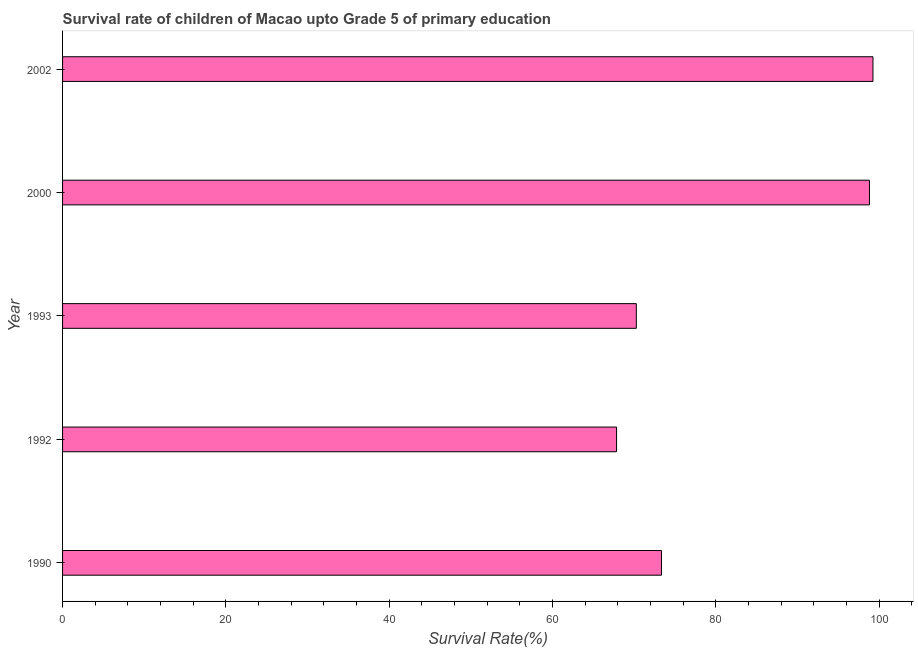Does the graph contain grids?
Provide a short and direct response. No. What is the title of the graph?
Provide a short and direct response. Survival rate of children of Macao upto Grade 5 of primary education. What is the label or title of the X-axis?
Give a very brief answer. Survival Rate(%). What is the survival rate in 1993?
Your answer should be very brief. 70.25. Across all years, what is the maximum survival rate?
Offer a terse response. 99.23. Across all years, what is the minimum survival rate?
Give a very brief answer. 67.83. In which year was the survival rate maximum?
Your answer should be compact. 2002. What is the sum of the survival rate?
Provide a short and direct response. 409.44. What is the difference between the survival rate in 1992 and 2002?
Your response must be concise. -31.39. What is the average survival rate per year?
Provide a short and direct response. 81.89. What is the median survival rate?
Make the answer very short. 73.33. In how many years, is the survival rate greater than 44 %?
Offer a terse response. 5. Do a majority of the years between 1990 and 1993 (inclusive) have survival rate greater than 72 %?
Provide a succinct answer. No. What is the ratio of the survival rate in 1990 to that in 1992?
Make the answer very short. 1.08. Is the difference between the survival rate in 2000 and 2002 greater than the difference between any two years?
Offer a very short reply. No. What is the difference between the highest and the second highest survival rate?
Your answer should be compact. 0.43. What is the difference between the highest and the lowest survival rate?
Provide a short and direct response. 31.4. What is the Survival Rate(%) in 1990?
Provide a short and direct response. 73.33. What is the Survival Rate(%) in 1992?
Your answer should be compact. 67.83. What is the Survival Rate(%) in 1993?
Your answer should be very brief. 70.25. What is the Survival Rate(%) of 2000?
Provide a succinct answer. 98.8. What is the Survival Rate(%) in 2002?
Provide a short and direct response. 99.23. What is the difference between the Survival Rate(%) in 1990 and 1992?
Your answer should be compact. 5.5. What is the difference between the Survival Rate(%) in 1990 and 1993?
Provide a succinct answer. 3.08. What is the difference between the Survival Rate(%) in 1990 and 2000?
Keep it short and to the point. -25.47. What is the difference between the Survival Rate(%) in 1990 and 2002?
Offer a very short reply. -25.9. What is the difference between the Survival Rate(%) in 1992 and 1993?
Keep it short and to the point. -2.42. What is the difference between the Survival Rate(%) in 1992 and 2000?
Offer a terse response. -30.96. What is the difference between the Survival Rate(%) in 1992 and 2002?
Your answer should be very brief. -31.4. What is the difference between the Survival Rate(%) in 1993 and 2000?
Keep it short and to the point. -28.54. What is the difference between the Survival Rate(%) in 1993 and 2002?
Ensure brevity in your answer.  -28.98. What is the difference between the Survival Rate(%) in 2000 and 2002?
Ensure brevity in your answer.  -0.43. What is the ratio of the Survival Rate(%) in 1990 to that in 1992?
Provide a short and direct response. 1.08. What is the ratio of the Survival Rate(%) in 1990 to that in 1993?
Provide a succinct answer. 1.04. What is the ratio of the Survival Rate(%) in 1990 to that in 2000?
Your answer should be very brief. 0.74. What is the ratio of the Survival Rate(%) in 1990 to that in 2002?
Ensure brevity in your answer.  0.74. What is the ratio of the Survival Rate(%) in 1992 to that in 2000?
Ensure brevity in your answer.  0.69. What is the ratio of the Survival Rate(%) in 1992 to that in 2002?
Your answer should be very brief. 0.68. What is the ratio of the Survival Rate(%) in 1993 to that in 2000?
Your response must be concise. 0.71. What is the ratio of the Survival Rate(%) in 1993 to that in 2002?
Provide a short and direct response. 0.71. What is the ratio of the Survival Rate(%) in 2000 to that in 2002?
Your answer should be very brief. 1. 